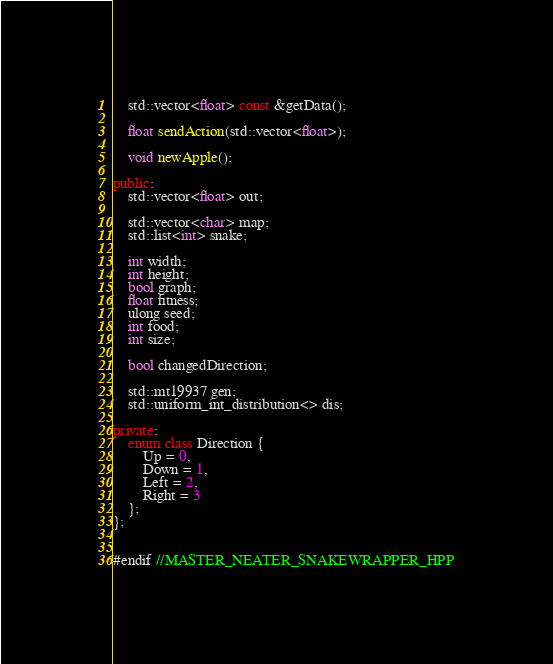Convert code to text. <code><loc_0><loc_0><loc_500><loc_500><_C++_>	std::vector<float> const &getData();

	float sendAction(std::vector<float>);

	void newApple();

public:
	std::vector<float> out;

	std::vector<char> map;
	std::list<int> snake;

	int width;
	int height;
	bool graph;
	float fitness;
	ulong seed;
	int food;
	int size;

	bool changedDirection;

	std::mt19937 gen;
	std::uniform_int_distribution<> dis;

private:
	enum class Direction {
		Up = 0,
		Down = 1,
		Left = 2,
		Right = 3
	};
};


#endif //MASTER_NEATER_SNAKEWRAPPER_HPP
</code> 